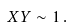Convert formula to latex. <formula><loc_0><loc_0><loc_500><loc_500>X Y \sim 1 \, .</formula> 